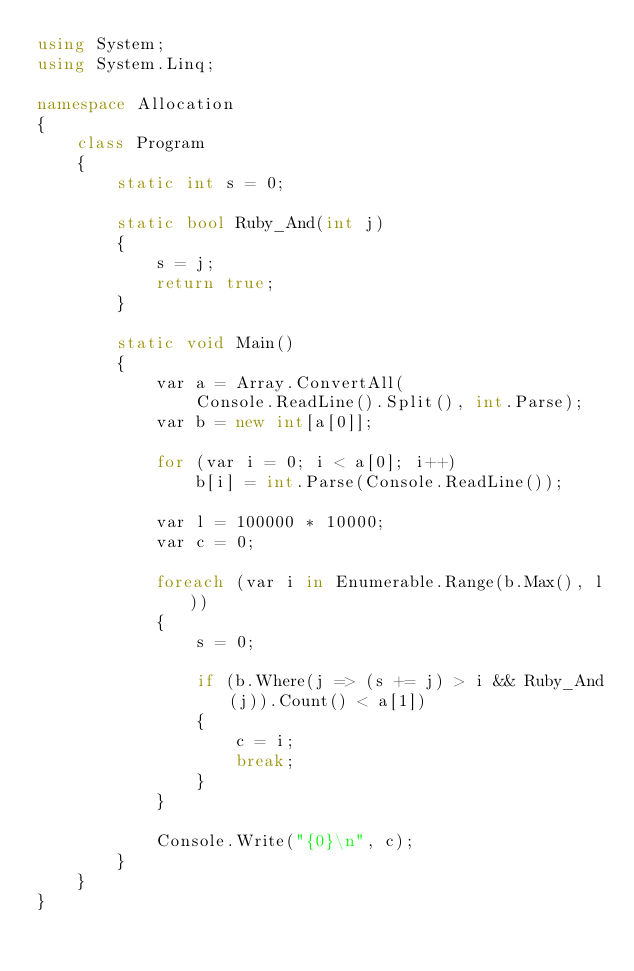<code> <loc_0><loc_0><loc_500><loc_500><_C#_>using System;
using System.Linq; 

namespace Allocation
{
    class Program
    {
        static int s = 0;

        static bool Ruby_And(int j)
        {
            s = j;
            return true;
        }

        static void Main()
        {
            var a = Array.ConvertAll(
                Console.ReadLine().Split(), int.Parse);
            var b = new int[a[0]];

            for (var i = 0; i < a[0]; i++)
                b[i] = int.Parse(Console.ReadLine());

            var l = 100000 * 10000;
            var c = 0;

            foreach (var i in Enumerable.Range(b.Max(), l))
            {
                s = 0;

                if (b.Where(j => (s += j) > i && Ruby_And(j)).Count() < a[1])
                {
                    c = i;
                    break;
                }
            }

            Console.Write("{0}\n", c);
        }
    }
}</code> 